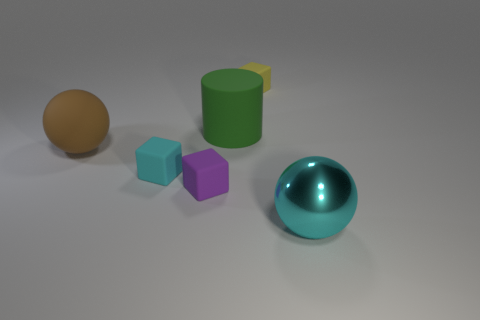What number of yellow objects have the same material as the purple thing?
Ensure brevity in your answer.  1. How many objects are large objects right of the yellow matte thing or red matte cylinders?
Offer a terse response. 1. The cyan metallic sphere is what size?
Your answer should be compact. Large. The big sphere to the left of the big object that is on the right side of the yellow rubber object is made of what material?
Give a very brief answer. Rubber. Does the block behind the green cylinder have the same size as the small purple object?
Offer a terse response. Yes. Are there any tiny rubber objects of the same color as the big metallic sphere?
Your response must be concise. Yes. What number of things are cyan objects that are behind the large cyan metal sphere or big objects behind the big shiny sphere?
Keep it short and to the point. 3. Is the rubber cylinder the same color as the shiny sphere?
Ensure brevity in your answer.  No. There is a small block that is the same color as the metallic ball; what material is it?
Ensure brevity in your answer.  Rubber. Are there fewer big objects behind the purple rubber cube than tiny purple matte cubes that are in front of the cyan sphere?
Make the answer very short. No. 